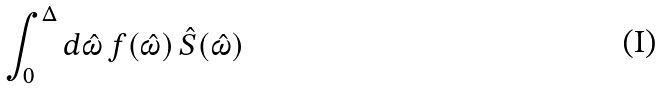<formula> <loc_0><loc_0><loc_500><loc_500>\int _ { 0 } ^ { \Delta } d \hat { \omega } \, f ( \hat { \omega } ) \, \hat { S } ( \hat { \omega } )</formula> 